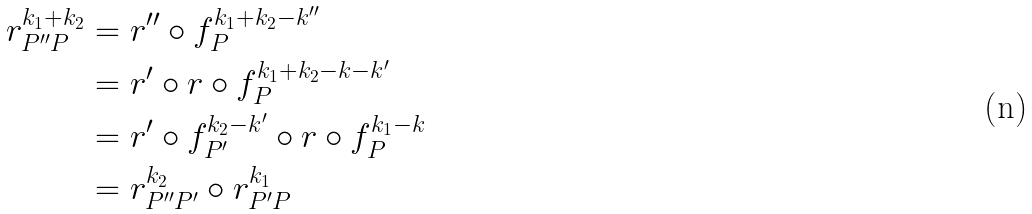Convert formula to latex. <formula><loc_0><loc_0><loc_500><loc_500>r ^ { k _ { 1 } + k _ { 2 } } _ { P ^ { \prime \prime } P } & = r ^ { \prime \prime } \circ f _ { P } ^ { k _ { 1 } + k _ { 2 } - k ^ { \prime \prime } } \\ & = r ^ { \prime } \circ r \circ f _ { P } ^ { k _ { 1 } + k _ { 2 } - k - k ^ { \prime } } \\ & = r ^ { \prime } \circ f _ { P ^ { \prime } } ^ { k _ { 2 } - k ^ { \prime } } \circ r \circ f _ { P } ^ { k _ { 1 } - k } \\ & = r ^ { k _ { 2 } } _ { P ^ { \prime \prime } P ^ { \prime } } \circ r ^ { k _ { 1 } } _ { P ^ { \prime } P }</formula> 